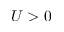Convert formula to latex. <formula><loc_0><loc_0><loc_500><loc_500>U > 0</formula> 